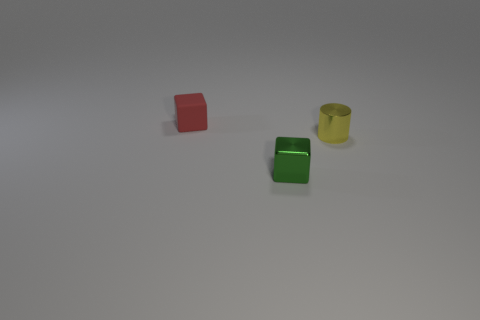Add 3 small blue metal balls. How many objects exist? 6 Subtract 0 purple cylinders. How many objects are left? 3 Subtract all cubes. How many objects are left? 1 Subtract 2 cubes. How many cubes are left? 0 Subtract all green blocks. Subtract all blue cylinders. How many blocks are left? 1 Subtract all cyan balls. How many red cubes are left? 1 Subtract all big yellow cylinders. Subtract all tiny yellow objects. How many objects are left? 2 Add 1 small yellow cylinders. How many small yellow cylinders are left? 2 Add 2 small rubber blocks. How many small rubber blocks exist? 3 Subtract all green cubes. How many cubes are left? 1 